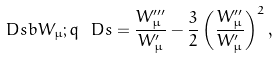<formula> <loc_0><loc_0><loc_500><loc_500>\ D s b { W _ { \mu } ; q } \ D s = \frac { W _ { \mu } ^ { \prime \prime \prime } } { W _ { \mu } ^ { \prime } } - \frac { 3 } { 2 } \left ( \frac { W _ { \mu } ^ { \prime \prime } } { W _ { \mu } ^ { \prime } } \right ) ^ { 2 } ,</formula> 